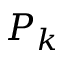<formula> <loc_0><loc_0><loc_500><loc_500>P _ { k }</formula> 